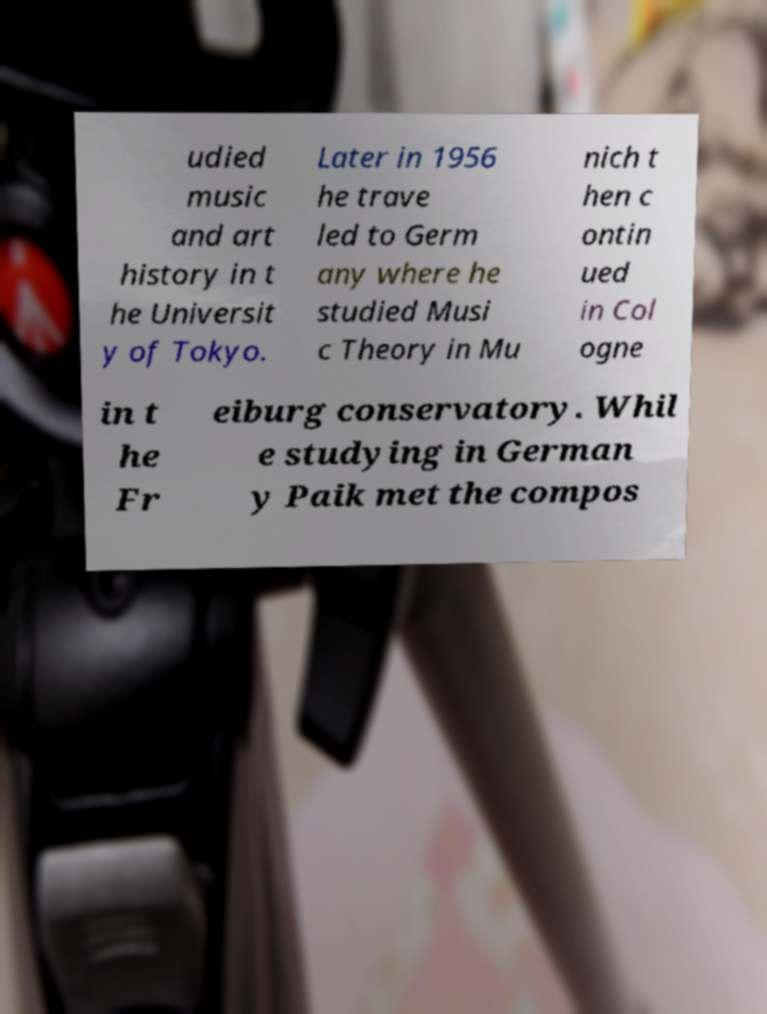Could you extract and type out the text from this image? udied music and art history in t he Universit y of Tokyo. Later in 1956 he trave led to Germ any where he studied Musi c Theory in Mu nich t hen c ontin ued in Col ogne in t he Fr eiburg conservatory. Whil e studying in German y Paik met the compos 